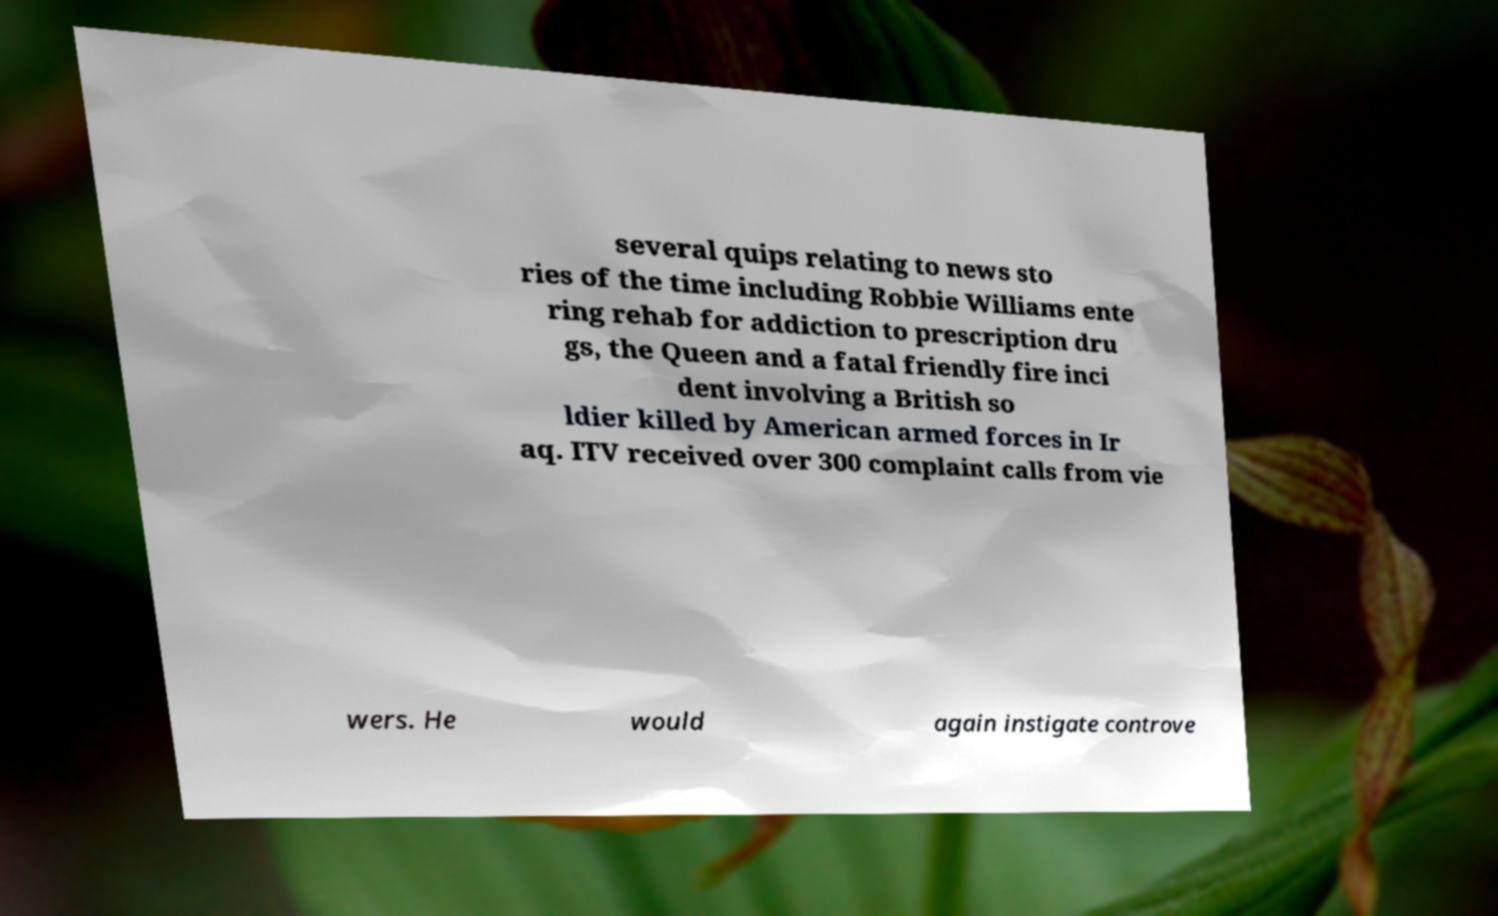Please identify and transcribe the text found in this image. several quips relating to news sto ries of the time including Robbie Williams ente ring rehab for addiction to prescription dru gs, the Queen and a fatal friendly fire inci dent involving a British so ldier killed by American armed forces in Ir aq. ITV received over 300 complaint calls from vie wers. He would again instigate controve 